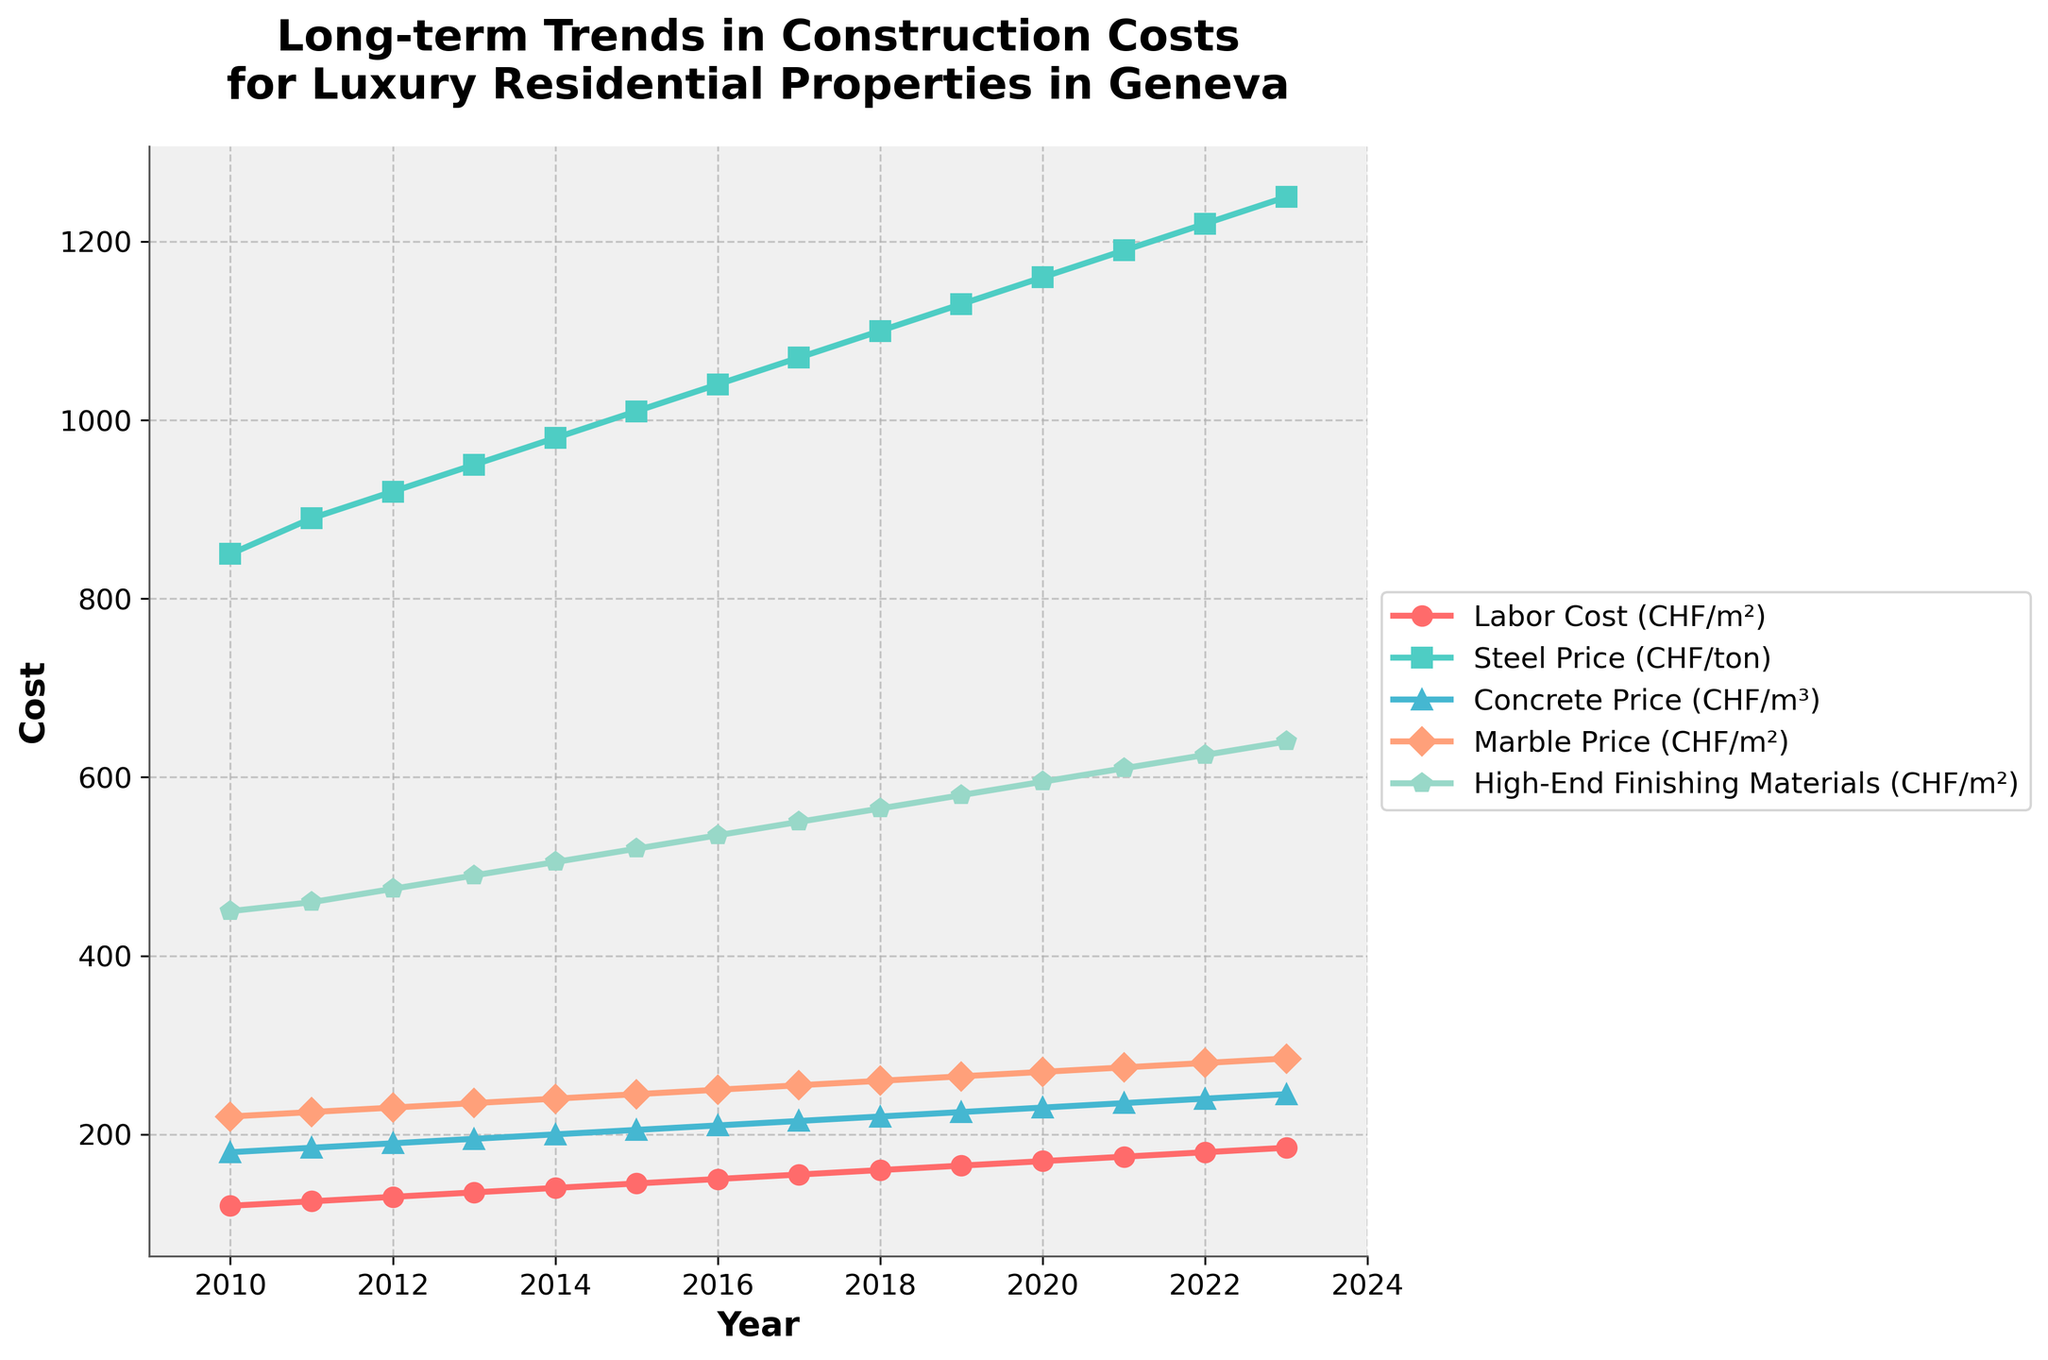What is the trend in labor cost from 2010 to 2023? The labor cost shows a consistent increasing trend from 120 CHF/m² in 2010 to 185 CHF/m² in 2023.
Answer: Increasing Which year saw the highest increase in steel price compared to the previous year? To find the highest year-on-year increase in steel price, we compare the differences: 2011: 40, 2012: 30, 2013: 30, 2014: 30, 2015: 30, 2016: 30, 2017: 30, 2018: 30, 2019: 30, 2020: 30, 2021: 30, 2022: 30, 2023: 30. The highest increase of 40 CHF/ton is in 2011.
Answer: 2011 How do the costs of marble and concrete compare in 2023? In 2023, the cost of marble is 285 CHF/m², and the cost of concrete is 245 CHF/m³. Marble is 40 CHF/m² more expensive than concrete.
Answer: Marble is 40 CHF/m² more expensive What is the average annual increase in high-end finishing materials from 2010 to 2023? The cost in 2010 is 450 CHF/m² and in 2023 it is 640 CHF/m². The total increase over 13 years is 640 - 450 = 190 CHF. The average annual increase is 190 / 13 ≈ 14.62 CHF/m².
Answer: 14.62 CHF/m² Between which two consecutive years did labor cost increase the most? By comparing annual increases: 2011: 5, 2012: 5, 2013: 5, 2014: 5, 2015: 5, 2016: 5, 2017: 5, 2018: 5, 2019: 5, 2020: 5, 2021: 5, 2022: 5, 2023: 5. All annual increases are the same at 5 CHF/m².
Answer: No difference Which cost component had the largest absolute increase from 2010 to 2023? We calculate the increase for each component: Labor Cost: 185 - 120 = 65 CHF/m², Steel Price: 1250 - 850 = 400 CHF/ton, Concrete Price: 245 - 180 = 65 CHF/m³, Marble Price: 285 - 220 = 65 CHF/m², High-End Finishing Materials: 640 - 450 = 190 CHF/m². Steel Price has the largest absolute increase of 400 CHF/ton.
Answer: Steel Price What was the labor cost in 2015 compared to the cost of high-end finishing materials in 2010? Labor cost in 2015 was 145 CHF/m² while the cost of high-end finishing materials in 2010 was 450 CHF/m². Labor cost was 305 CHF/m² lower.
Answer: 305 CHF/m² lower Do any of the cost components show a decreasing trend? None of the cost components (Labor Cost, Steel Price, Concrete Price, Marble Price, High-End Finishing Materials) show a decreasing trend; all increase over time.
Answer: No 